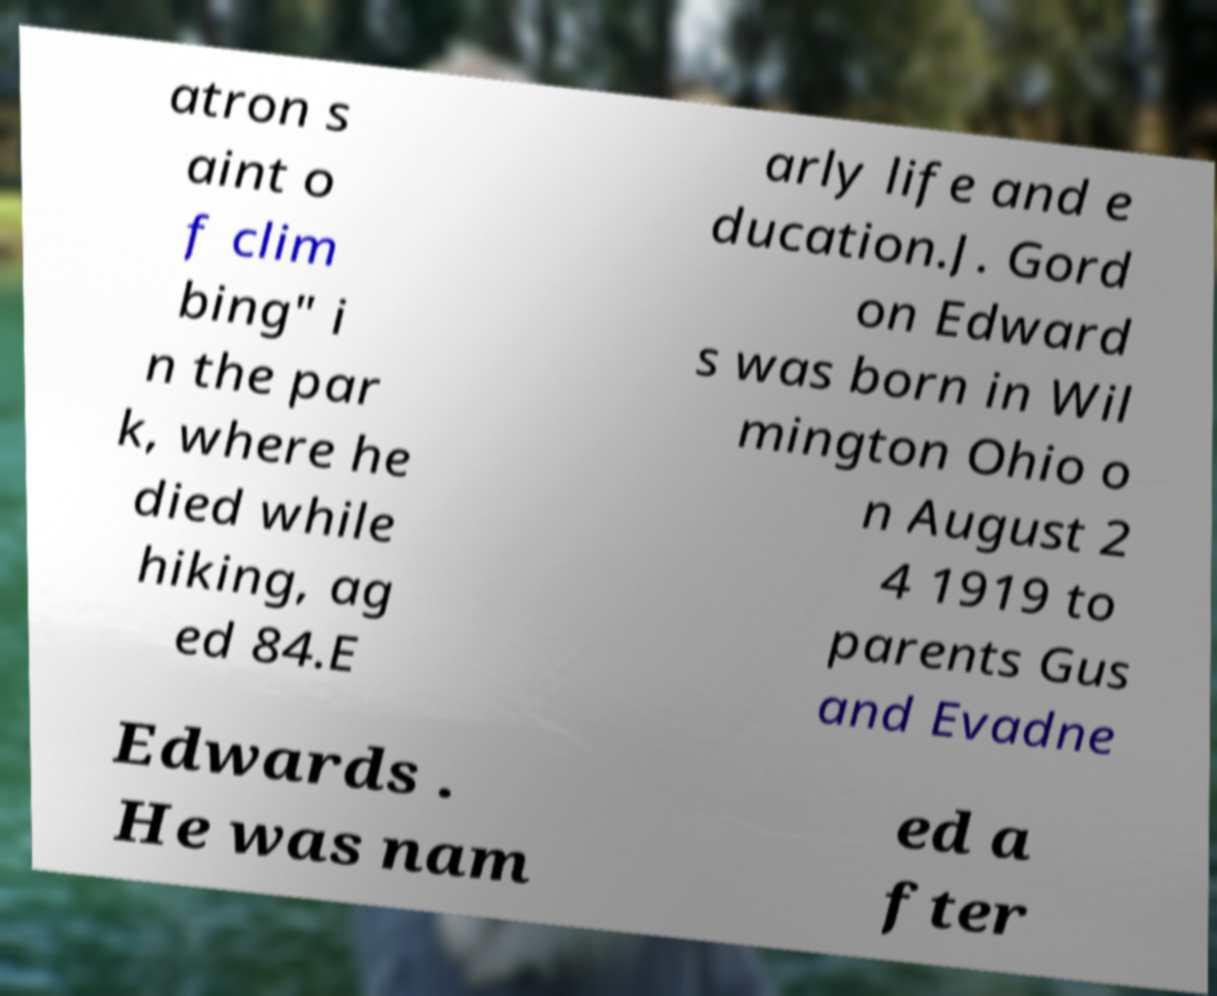For documentation purposes, I need the text within this image transcribed. Could you provide that? atron s aint o f clim bing" i n the par k, where he died while hiking, ag ed 84.E arly life and e ducation.J. Gord on Edward s was born in Wil mington Ohio o n August 2 4 1919 to parents Gus and Evadne Edwards . He was nam ed a fter 